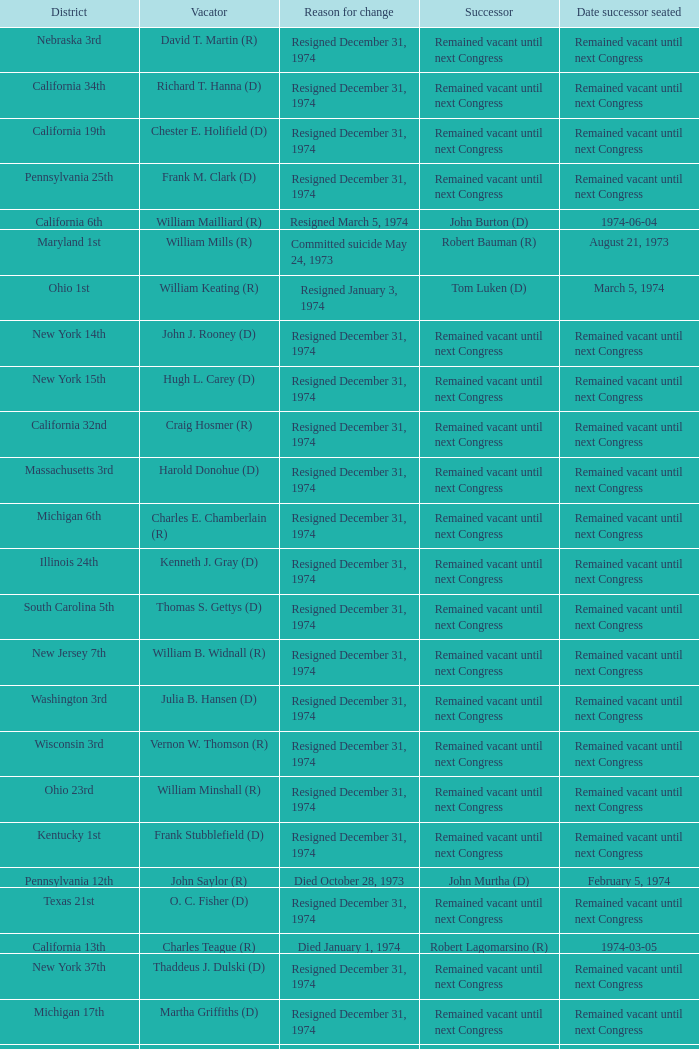When was the date successor seated when the vacator was charles e. chamberlain (r)? Remained vacant until next Congress. 